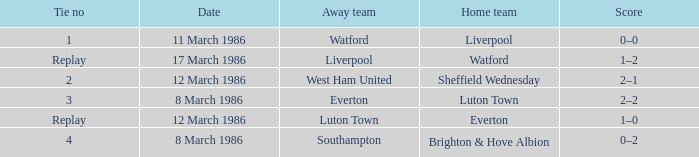What was the tie resulting from Sheffield Wednesday's game? 2.0. Would you be able to parse every entry in this table? {'header': ['Tie no', 'Date', 'Away team', 'Home team', 'Score'], 'rows': [['1', '11 March 1986', 'Watford', 'Liverpool', '0–0'], ['Replay', '17 March 1986', 'Liverpool', 'Watford', '1–2'], ['2', '12 March 1986', 'West Ham United', 'Sheffield Wednesday', '2–1'], ['3', '8 March 1986', 'Everton', 'Luton Town', '2–2'], ['Replay', '12 March 1986', 'Luton Town', 'Everton', '1–0'], ['4', '8 March 1986', 'Southampton', 'Brighton & Hove Albion', '0–2']]} 